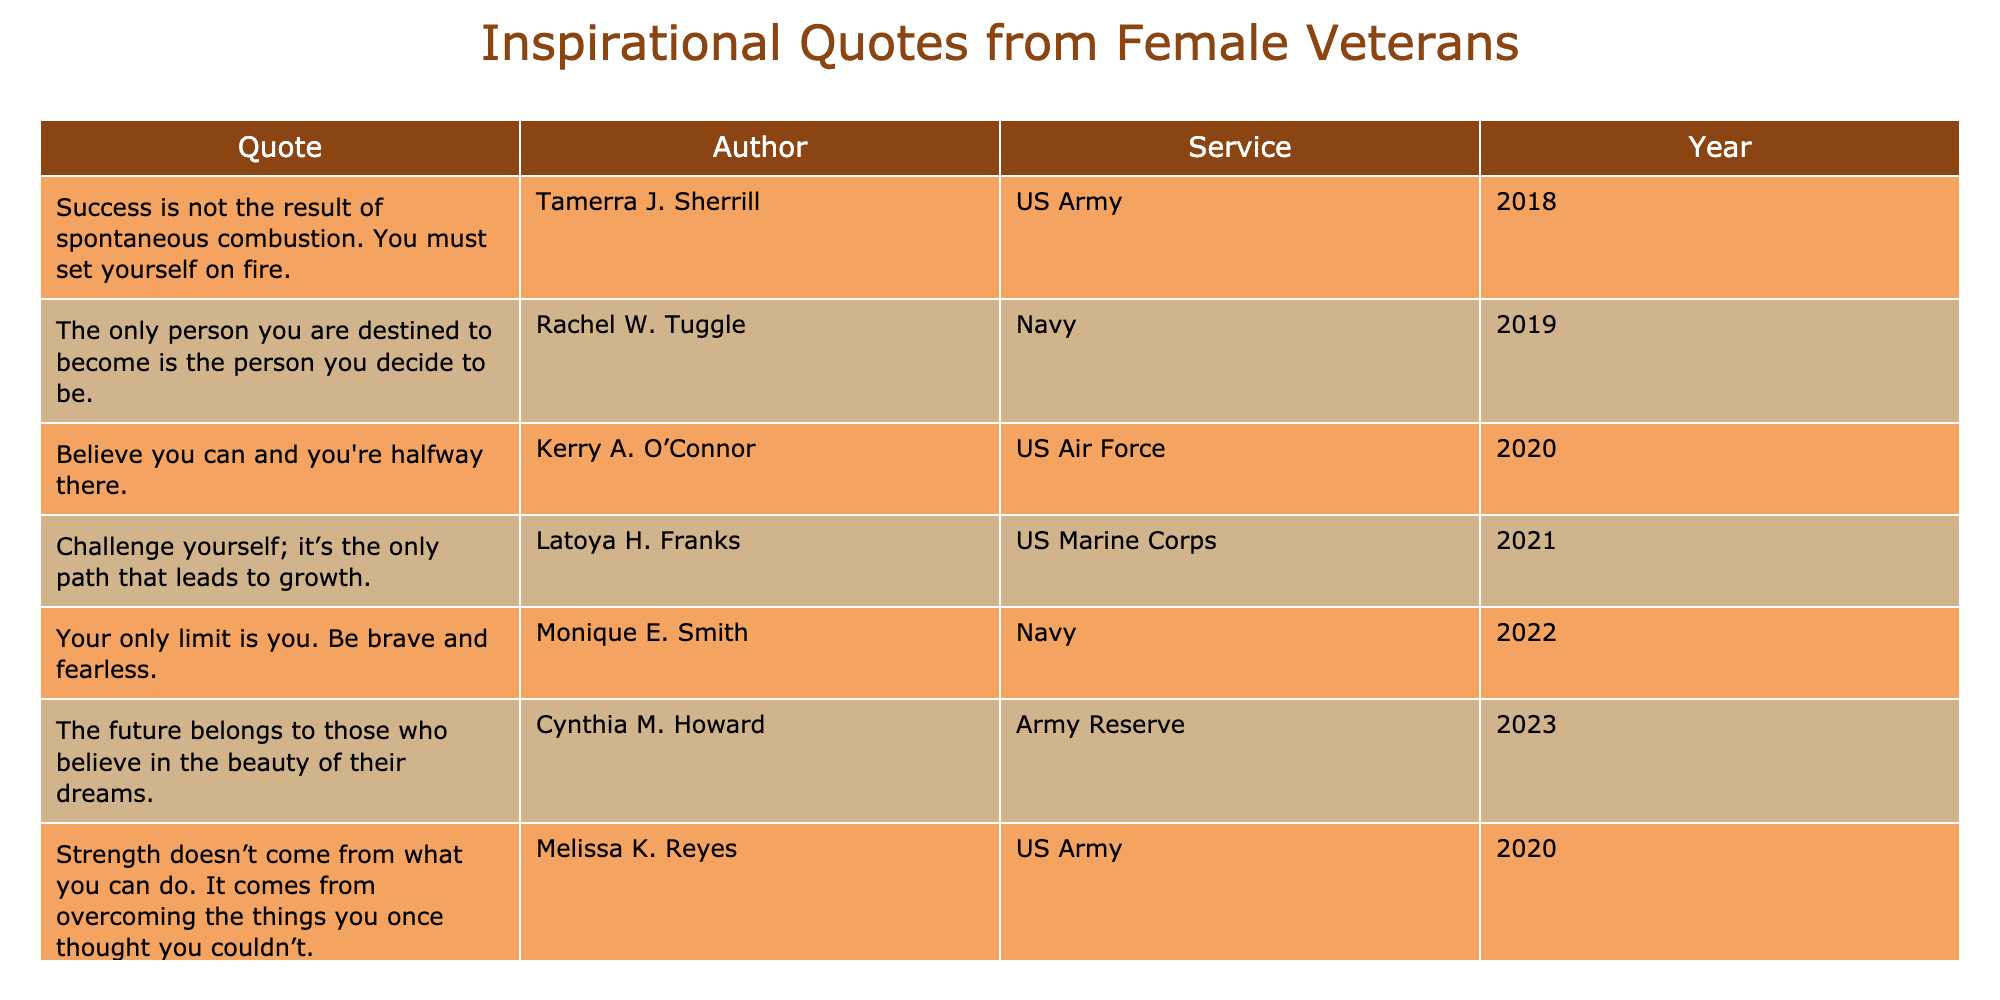What year did Tamerra J. Sherrill share her quote? Tamerra J. Sherrill's quote is listed under the year 2018 in the table, indicating that was when she shared it.
Answer: 2018 Which service does Rachel W. Tuggle belong to? The table specifically mentions that Rachel W. Tuggle served in the Navy.
Answer: Navy How many quotes were shared in the year 2021? Two quotes are shared in the year 2021 by Latoya H. Franks and Erica J. Gray, which can be counted directly from the table entries for that year.
Answer: 2 What is the difference in years between the quotes shared by Melissa K. Reyes and Cynthia M. Howard? Melissa K. Reyes shared her quote in 2020 and Cynthia M. Howard in 2023. The difference is calculated as 2023 - 2020 = 3 years.
Answer: 3 Is it true that all quotes are from female veterans of the US Army? The table reveals that quotes come from various branches including the Army, Navy, Marine Corps, and Air Force, so not all are from the Army.
Answer: No What is the average year of the quotes shared whose authors are from the Navy? Rachel W. Tuggle's quote is from 2019 and Monique E. Smith's is from 2022. To find the average, sum the years (2019 + 2022 = 4041) and divide by 2; thus, the average is 2020.5, rounded to 2021.
Answer: 2021 Which author had the most recent quote and what is the quote? Cynthia M. Howard's quote from 2023 is the most recent. It is, "The future belongs to those who believe in the beauty of their dreams." This can be identified by checking the year column for the highest value.
Answer: "The future belongs to those who believe in the beauty of their dreams." How many quotes were shared by authors from the US Army? Tamerra J. Sherrill and Melissa K. Reyes both contributed quotes, accounting for a total of 2 quotes from authors affiliated with the US Army based on the entries in the table.
Answer: 2 What percentage of the quotes originate from the US Marine Corps? There are two quotes from authors associated with the US Marine Corps (Latoya H. Franks and Erica J. Gray) out of a total of 8 quotes. The percentage is calculated as (2/8) * 100 = 25%.
Answer: 25% 